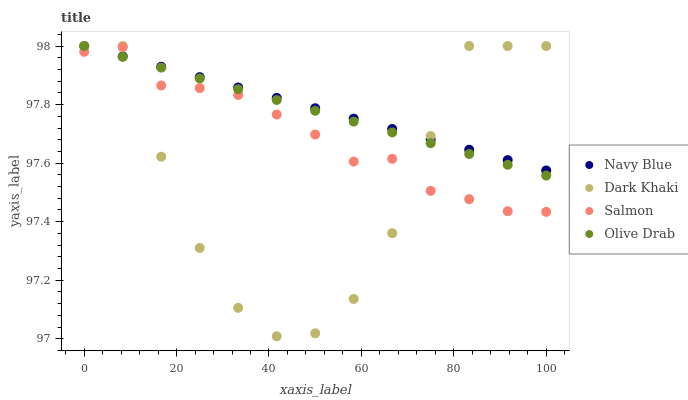Does Dark Khaki have the minimum area under the curve?
Answer yes or no. Yes. Does Navy Blue have the maximum area under the curve?
Answer yes or no. Yes. Does Salmon have the minimum area under the curve?
Answer yes or no. No. Does Salmon have the maximum area under the curve?
Answer yes or no. No. Is Olive Drab the smoothest?
Answer yes or no. Yes. Is Dark Khaki the roughest?
Answer yes or no. Yes. Is Navy Blue the smoothest?
Answer yes or no. No. Is Navy Blue the roughest?
Answer yes or no. No. Does Dark Khaki have the lowest value?
Answer yes or no. Yes. Does Salmon have the lowest value?
Answer yes or no. No. Does Olive Drab have the highest value?
Answer yes or no. Yes. Does Salmon have the highest value?
Answer yes or no. No. Does Dark Khaki intersect Salmon?
Answer yes or no. Yes. Is Dark Khaki less than Salmon?
Answer yes or no. No. Is Dark Khaki greater than Salmon?
Answer yes or no. No. 